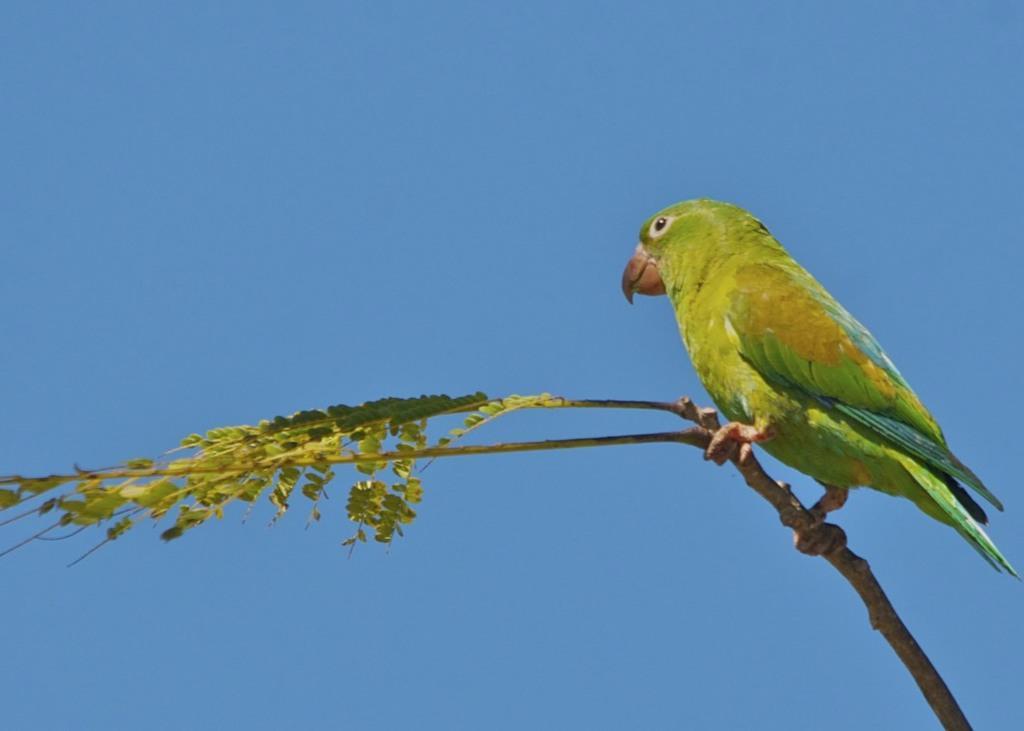Describe this image in one or two sentences. In the foreground I can see a parrot is sitting on the branch of a tree. In the background I can see the blue sky. This image is taken may be during a day. 